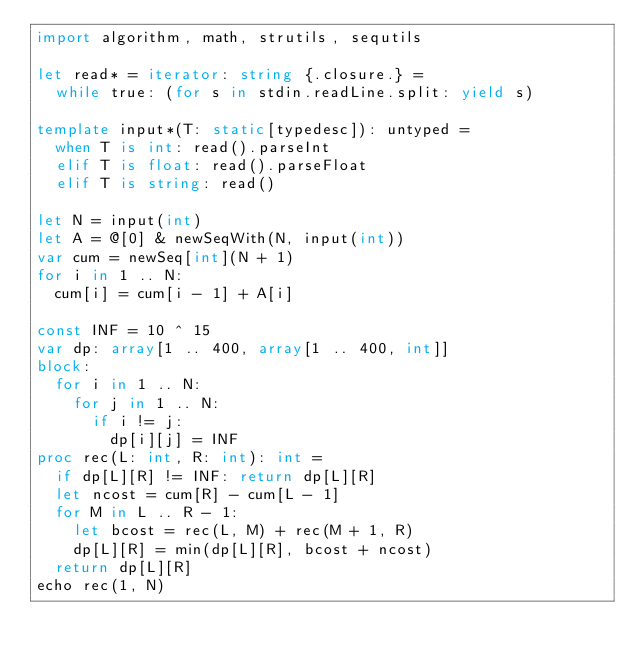Convert code to text. <code><loc_0><loc_0><loc_500><loc_500><_Nim_>import algorithm, math, strutils, sequtils

let read* = iterator: string {.closure.} =
  while true: (for s in stdin.readLine.split: yield s)

template input*(T: static[typedesc]): untyped =
  when T is int: read().parseInt
  elif T is float: read().parseFloat
  elif T is string: read()

let N = input(int)
let A = @[0] & newSeqWith(N, input(int))
var cum = newSeq[int](N + 1)
for i in 1 .. N:
  cum[i] = cum[i - 1] + A[i]

const INF = 10 ^ 15
var dp: array[1 .. 400, array[1 .. 400, int]]
block:
  for i in 1 .. N:
    for j in 1 .. N:
      if i != j:
        dp[i][j] = INF
proc rec(L: int, R: int): int =
  if dp[L][R] != INF: return dp[L][R]
  let ncost = cum[R] - cum[L - 1]
  for M in L .. R - 1:
    let bcost = rec(L, M) + rec(M + 1, R)
    dp[L][R] = min(dp[L][R], bcost + ncost)
  return dp[L][R]
echo rec(1, N)</code> 